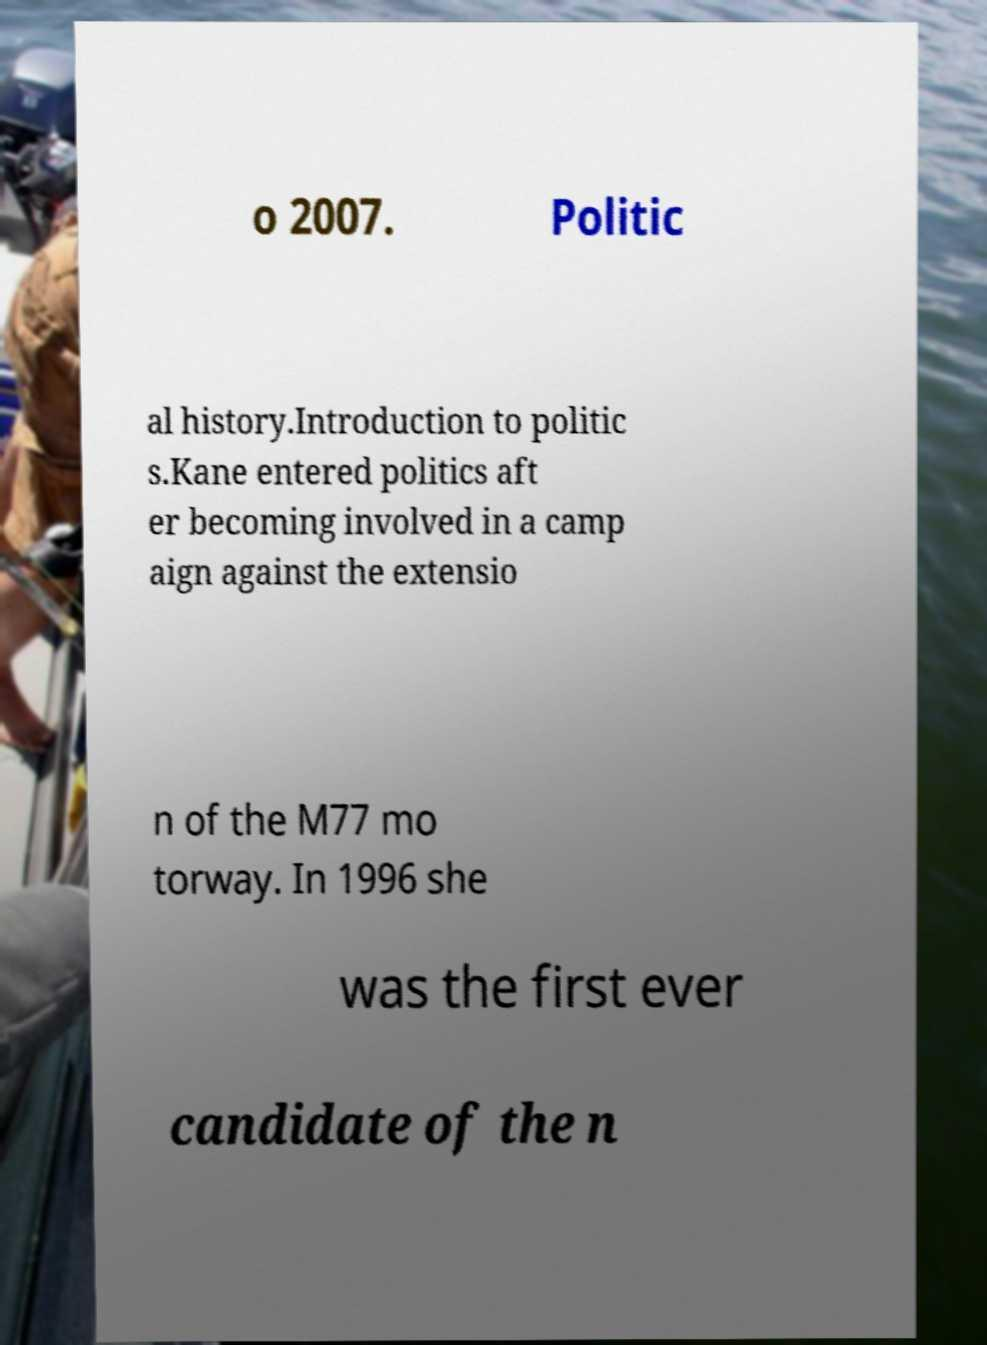Could you assist in decoding the text presented in this image and type it out clearly? o 2007. Politic al history.Introduction to politic s.Kane entered politics aft er becoming involved in a camp aign against the extensio n of the M77 mo torway. In 1996 she was the first ever candidate of the n 